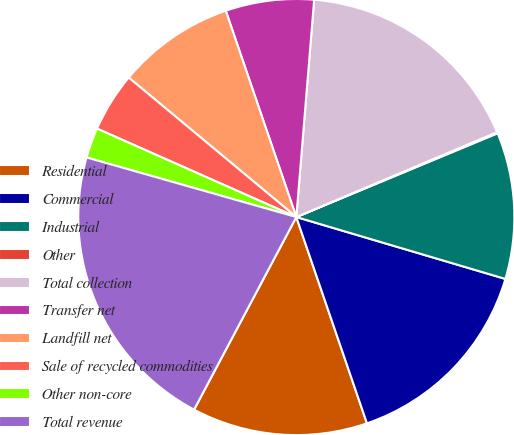Convert chart to OTSL. <chart><loc_0><loc_0><loc_500><loc_500><pie_chart><fcel>Residential<fcel>Commercial<fcel>Industrial<fcel>Other<fcel>Total collection<fcel>Transfer net<fcel>Landfill net<fcel>Sale of recycled commodities<fcel>Other non-core<fcel>Total revenue<nl><fcel>13.02%<fcel>15.17%<fcel>10.86%<fcel>0.09%<fcel>17.33%<fcel>6.55%<fcel>8.71%<fcel>4.4%<fcel>2.24%<fcel>21.64%<nl></chart> 